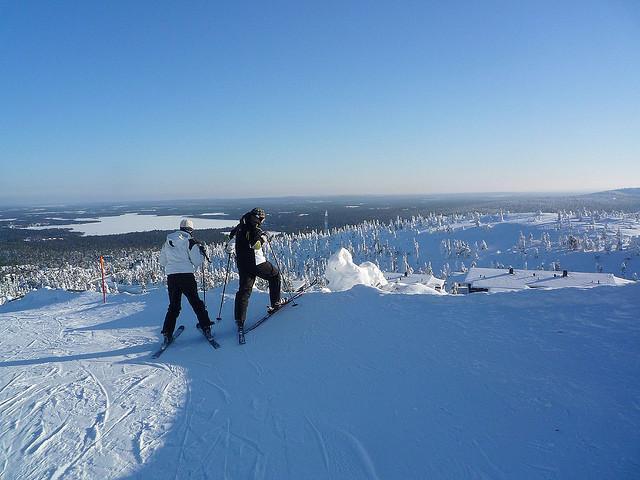How many people are shown?
Give a very brief answer. 2. How many people are visible?
Give a very brief answer. 2. 